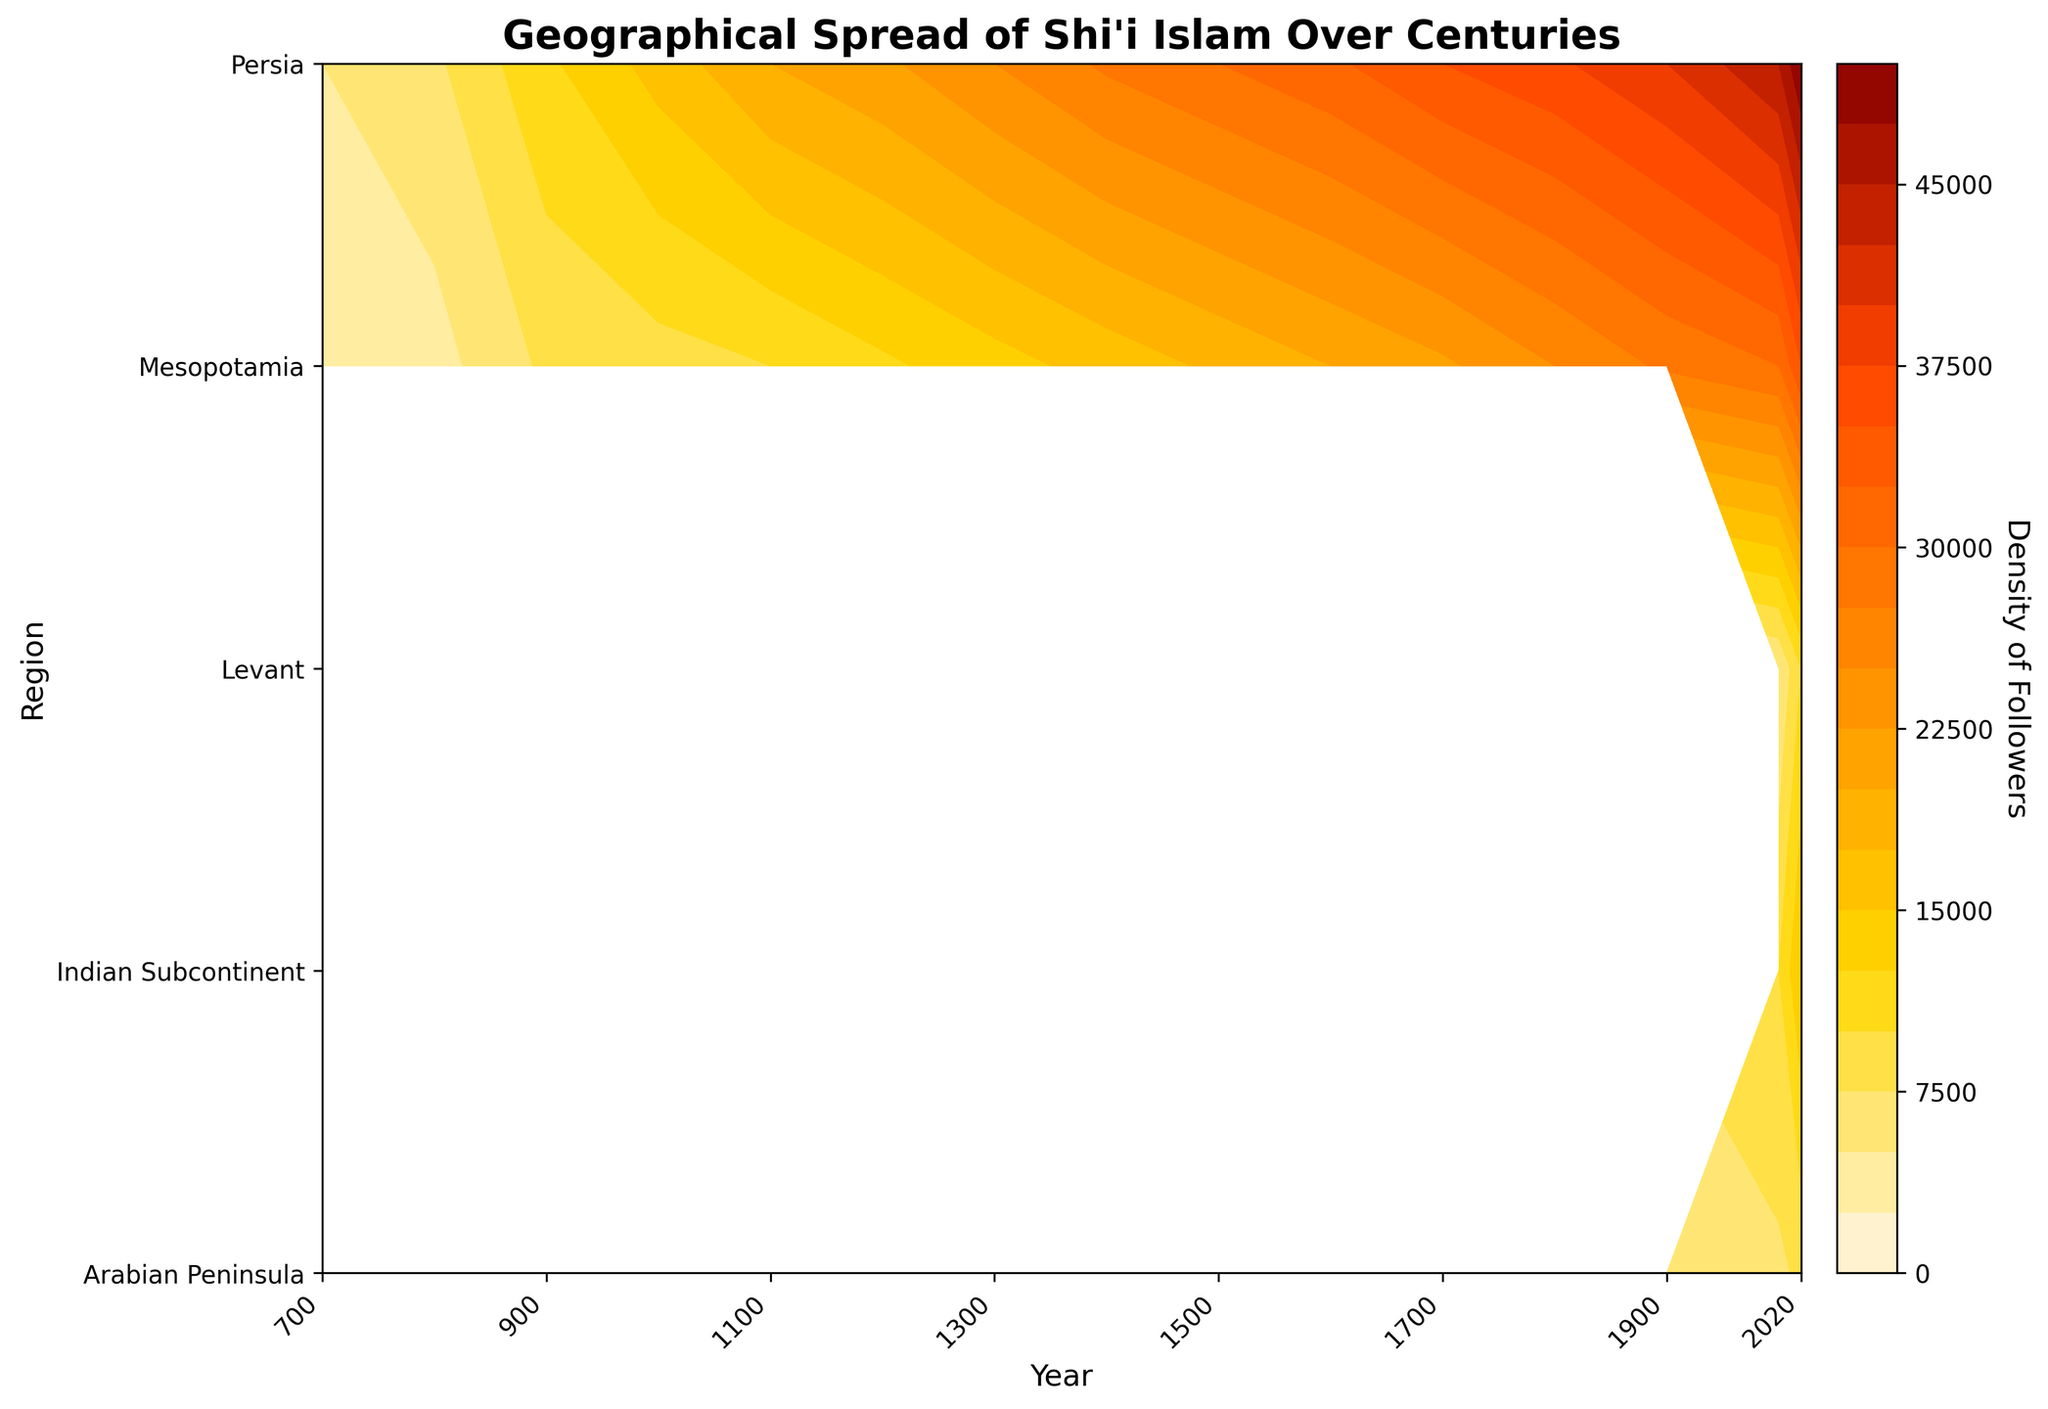What is the title of the plot? The title of the plot is displayed at the top. It reads 'Geographical Spread of Shi'i Islam Over Centuries'.
Answer: Geographical Spread of Shi'i Islam Over Centuries Which region shows the highest density of followers in the year 1000? By looking at the contour data for the year 1000, the region "Persia" has the highest density of followers. The number is seen at the peak annotation.
Answer: Persia How does the density of followers in the Arabian Peninsula change from 700 to 2020? To assess the change, look at the contour gradient for the Arabian Peninsula from 700 to 2020. The density increases over time as indicated by contour levels that get denser over the years.
Answer: It increases Compare the density of followers between Persia and Mesopotamia in the year 1500. For the year 1500, the density for Persia is 30000 and for Mesopotamia is 18000, as indicated by the annotations on the plot.
Answer: Persia has more followers than Mesopotamia Which region has the lowest density of followers in the year 2020? The plot shows the lowest density annotation in the Arabian Peninsula for the year 2020.
Answer: Arabian Peninsula How many regions are included in the plot for the year 2020? By looking at the x-axis ticks and confirming with annotated data points for the year 2020, we see that there are five regions: Persia, Mesopotamia, Arabian Peninsula, Indian Subcontinent, and Levant.
Answer: Five regions Explain the pattern of density changes in Mesopotamia from 700 to 2020. The density in Mesopotamia starts at 3000 in 700 and consistently increases to 35000 in 2020. The increase is mostly steady with minor fluctuations as observed in the contour levels.
Answer: Steady increase with minor fluctuations Identify the region that appeared in the dataset only after the year 2000. The contour plot shows the Indian Subcontinent and Levant regions appearing only post-2000.
Answer: Indian Subcontinent and Levant What can be inferred about the growth trend of Shi'i Islam in Persia relative to other regions? The contour plot shows that Persia consistently has the highest density of followers across all years, suggesting a strong growth trend relative to other regions.
Answer: Stronger growth trend Calculate the density difference between Persia and the Arabian Peninsula in the year 1700. In 1700, Persia has a density of 35000 and Arabian Peninsula has 4000. The difference is 35000 - 4000 = 31000.
Answer: 31000 